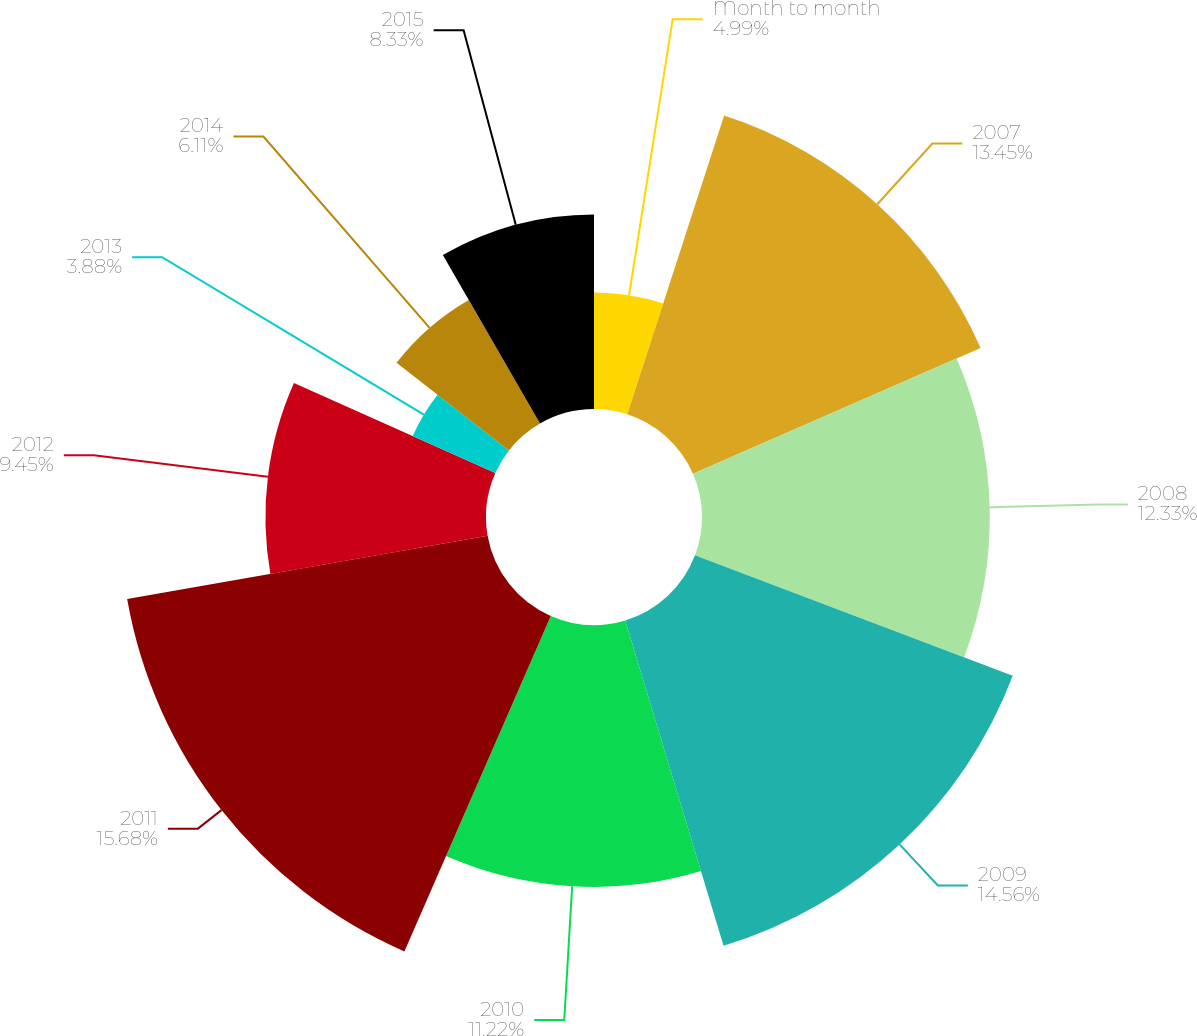<chart> <loc_0><loc_0><loc_500><loc_500><pie_chart><fcel>Month to month<fcel>2007<fcel>2008<fcel>2009<fcel>2010<fcel>2011<fcel>2012<fcel>2013<fcel>2014<fcel>2015<nl><fcel>4.99%<fcel>13.45%<fcel>12.33%<fcel>14.56%<fcel>11.22%<fcel>15.68%<fcel>9.45%<fcel>3.88%<fcel>6.11%<fcel>8.33%<nl></chart> 